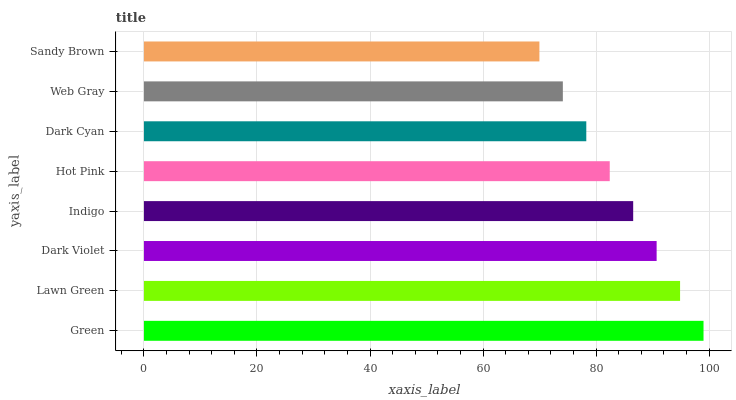Is Sandy Brown the minimum?
Answer yes or no. Yes. Is Green the maximum?
Answer yes or no. Yes. Is Lawn Green the minimum?
Answer yes or no. No. Is Lawn Green the maximum?
Answer yes or no. No. Is Green greater than Lawn Green?
Answer yes or no. Yes. Is Lawn Green less than Green?
Answer yes or no. Yes. Is Lawn Green greater than Green?
Answer yes or no. No. Is Green less than Lawn Green?
Answer yes or no. No. Is Indigo the high median?
Answer yes or no. Yes. Is Hot Pink the low median?
Answer yes or no. Yes. Is Green the high median?
Answer yes or no. No. Is Lawn Green the low median?
Answer yes or no. No. 